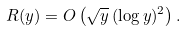<formula> <loc_0><loc_0><loc_500><loc_500>R ( y ) = O \left ( \sqrt { y } \, ( \log y ) ^ { 2 } \right ) .</formula> 